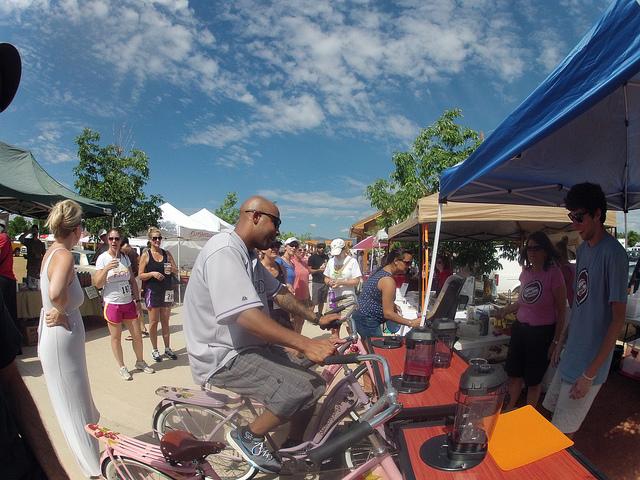What is the man riding?
Write a very short answer. Bicycle. Is the sky clear?
Answer briefly. No. What color is the blonde woman's pants suit?
Write a very short answer. White. 